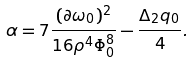<formula> <loc_0><loc_0><loc_500><loc_500>\alpha = 7 \frac { ( \partial \omega _ { 0 } ) ^ { 2 } } { 1 6 \rho ^ { 4 } \Phi _ { 0 } ^ { 8 } } - \frac { \Delta _ { 2 } q _ { 0 } } { 4 } .</formula> 